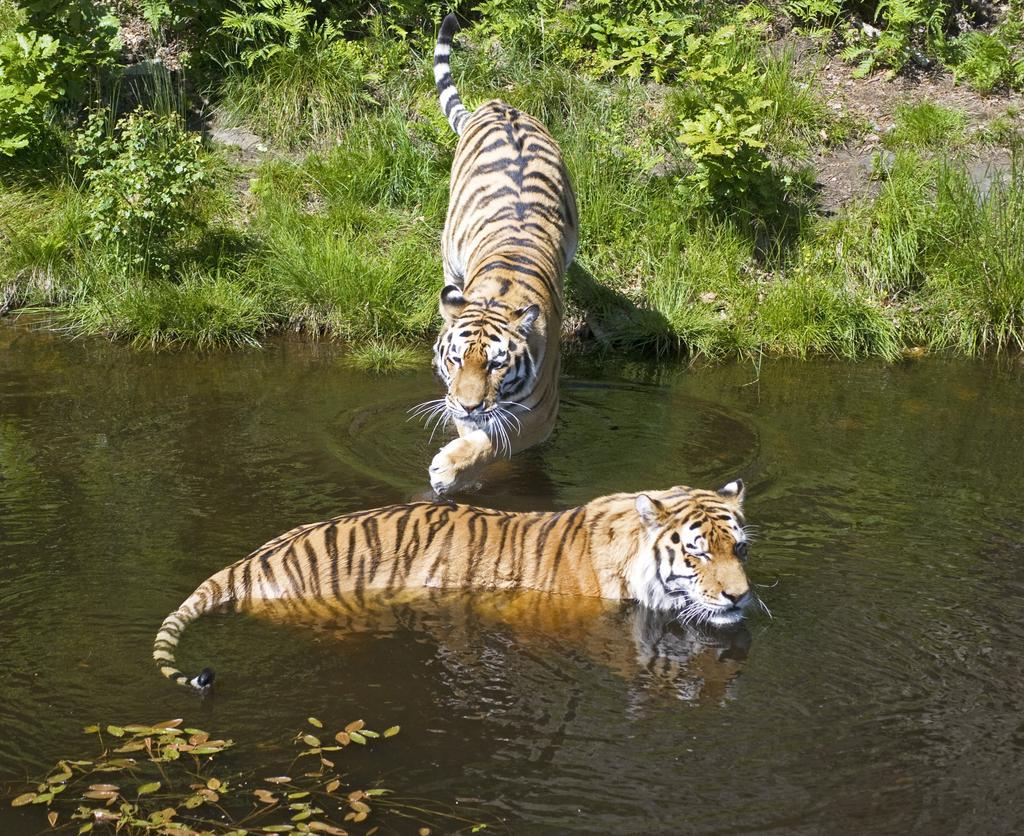Can you describe this image briefly? There are two tigers in the water. In the back there are plants. 